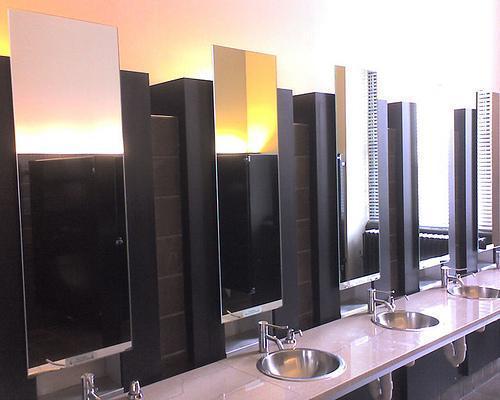How many sinks are there?
Give a very brief answer. 4. How many pipes?
Give a very brief answer. 2. How many mirrors?
Give a very brief answer. 5. How many sets of pipes?
Give a very brief answer. 2. 